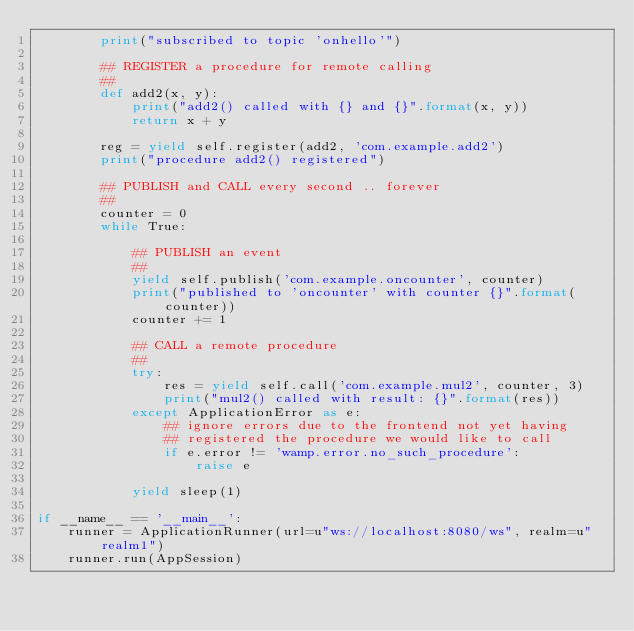<code> <loc_0><loc_0><loc_500><loc_500><_Python_>        print("subscribed to topic 'onhello'")

        ## REGISTER a procedure for remote calling
        ##
        def add2(x, y):
            print("add2() called with {} and {}".format(x, y))
            return x + y

        reg = yield self.register(add2, 'com.example.add2')
        print("procedure add2() registered")

        ## PUBLISH and CALL every second .. forever
        ##
        counter = 0
        while True:

            ## PUBLISH an event
            ##
            yield self.publish('com.example.oncounter', counter)
            print("published to 'oncounter' with counter {}".format(counter))
            counter += 1

            ## CALL a remote procedure
            ##
            try:
                res = yield self.call('com.example.mul2', counter, 3)
                print("mul2() called with result: {}".format(res))
            except ApplicationError as e:
                ## ignore errors due to the frontend not yet having
                ## registered the procedure we would like to call
                if e.error != 'wamp.error.no_such_procedure':
                    raise e

            yield sleep(1)

if __name__ == '__main__':
    runner = ApplicationRunner(url=u"ws://localhost:8080/ws", realm=u"realm1")
    runner.run(AppSession)
</code> 